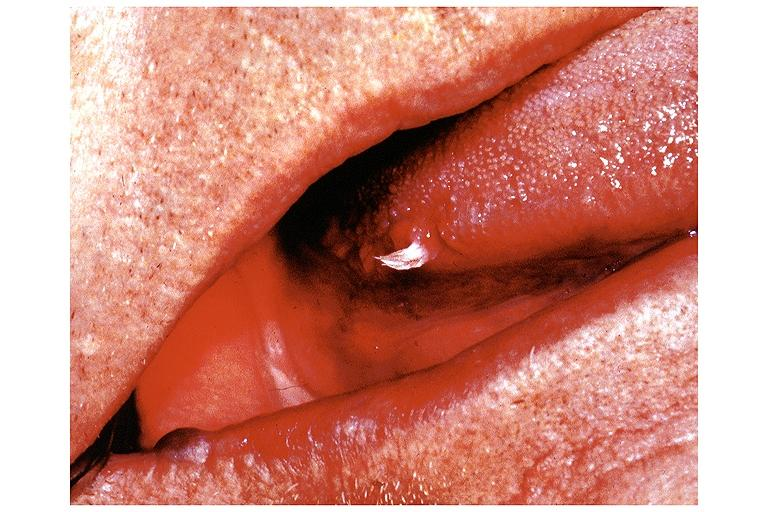s splenomegaly with cirrhosis present?
Answer the question using a single word or phrase. No 